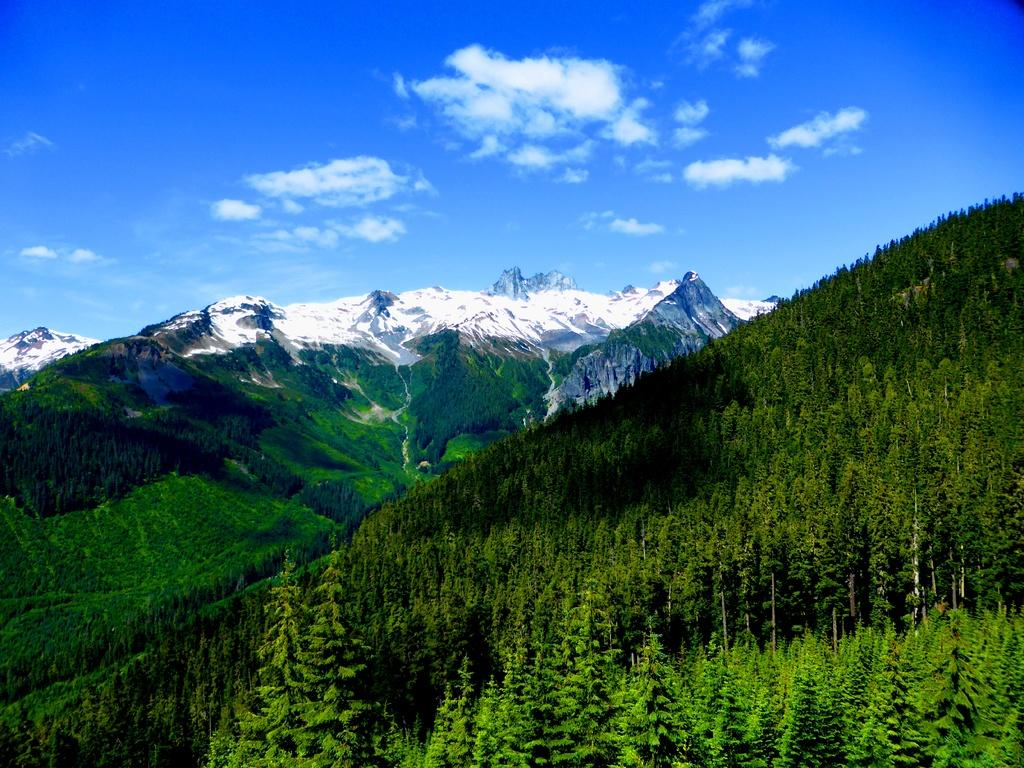What type of landscape is depicted in the image? The image features mountains with snow. What type of vegetation can be seen at the bottom of the mountains? There are trees at the bottom of the image. What is visible at the top of the image? The sky is visible at the top of the image. What can be seen in the sky in the image? Clouds are present in the sky. What type of transportation system is visible in the image? There is no transportation system visible in the image; it features mountains, trees, sky, and clouds. 